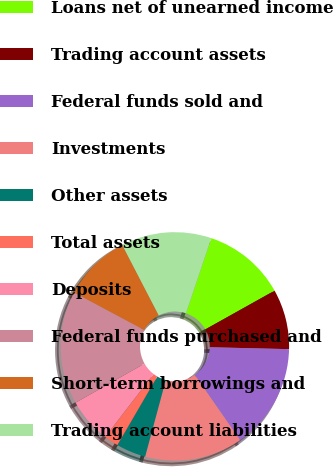Convert chart to OTSL. <chart><loc_0><loc_0><loc_500><loc_500><pie_chart><fcel>Loans net of unearned income<fcel>Trading account assets<fcel>Federal funds sold and<fcel>Investments<fcel>Other assets<fcel>Total assets<fcel>Deposits<fcel>Federal funds purchased and<fcel>Short-term borrowings and<fcel>Trading account liabilities<nl><fcel>11.72%<fcel>8.5%<fcel>14.94%<fcel>13.87%<fcel>4.2%<fcel>2.05%<fcel>6.35%<fcel>16.02%<fcel>9.57%<fcel>12.79%<nl></chart> 